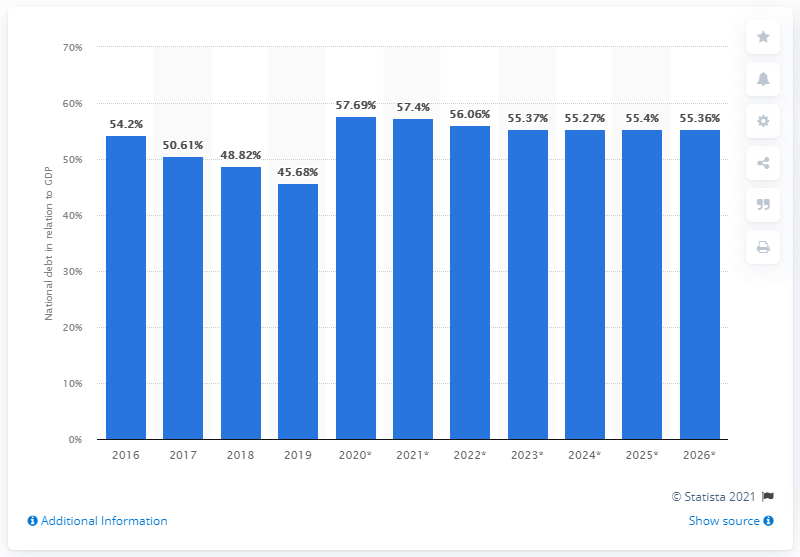Mention a couple of crucial points in this snapshot. In 2019, the national debt of Poland accounted for 45.68% of the country's GDP. 